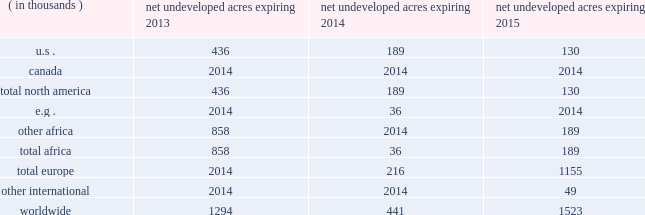In the ordinary course of business , based on our evaluations of certain geologic trends and prospective economics , we have allowed certain lease acreage to expire and may allow additional acreage to expire in the future .
If production is not established or we take no other action to extend the terms of the leases , licenses , or concessions , undeveloped acreage listed in the table below will expire over the next three years .
We plan to continue the terms of many of these licenses and concession areas or retain leases through operational or administrative actions. .
Marketing and midstream our e&p segment includes activities related to the marketing and transportation of substantially all of our liquid hydrocarbon and natural gas production .
These activities include the transportation of production to market centers , the sale of commodities to third parties and storage of production .
We balance our various sales , storage and transportation positions through what we call supply optimization , which can include the purchase of commodities from third parties for resale .
Supply optimization serves to aggregate volumes in order to satisfy transportation commitments and to achieve flexibility within product types and delivery points .
As discussed previously , we currently own and operate gathering systems and other midstream assets in some of our production areas .
We are continually evaluating value-added investments in midstream infrastructure or in capacity in third-party systems .
Delivery commitments we have committed to deliver quantities of crude oil and natural gas to customers under a variety of contracts .
As of december 31 , 2012 , those contracts for fixed and determinable amounts relate primarily to eagle ford liquid hydrocarbon production .
A minimum of 54 mbbld is to be delivered at variable pricing through mid-2017 under two contracts .
Our current production rates and proved reserves related to the eagle ford shale are sufficient to meet these commitments , but the contracts also provide for a monetary shortfall penalty or delivery of third-party volumes .
Oil sands mining segment we hold a 20 percent non-operated interest in the aosp , an oil sands mining and upgrading joint venture located in alberta , canada .
The joint venture produces bitumen from oil sands deposits in the athabasca region utilizing mining techniques and upgrades the bitumen to synthetic crude oils and vacuum gas oil .
The aosp 2019s mining and extraction assets are located near fort mcmurray , alberta and include the muskeg river and the jackpine mines .
Gross design capacity of the combined mines is 255000 ( 51000 net to our interest ) barrels of bitumen per day .
The aosp base and expansion 1 scotford upgrader is at fort saskatchewan , northeast of edmonton , alberta .
As of december 31 , 2012 , we own or have rights to participate in developed and undeveloped leases totaling approximately 216000 gross ( 43000 net ) acres .
The underlying developed leases are held for the duration of the project , with royalties payable to the province of alberta .
The five year aosp expansion 1 was completed in 2011 .
The jackpine mine commenced production under a phased start- up in the third quarter of 2010 and began supplying oil sands ore to the base processing facility in the fourth quarter of 2010 .
The upgrader expansion was completed and commenced operations in the second quarter of 2011 .
Synthetic crude oil sales volumes for 2012 were 47 mbbld and net of royalty production was 41 mbbld .
Phase one of debottlenecking opportunities was approved in 2011 and is expected to be completed in the second quarter of 2013 .
Future expansions and additional debottlenecking opportunities remain under review with no formal approvals expected until 2014 .
Current aosp operations use established processes to mine oil sands deposits from an open-pit mine , extract the bitumen and upgrade it into synthetic crude oils .
Ore is mined using traditional truck and shovel mining techniques .
The mined ore passes through primary crushers to reduce the ore chunks in size and is then sent to rotary breakers where the ore chunks are further reduced to smaller particles .
The particles are combined with hot water to create slurry .
The slurry moves through the extraction .
What percent of net expiring acres in 2013 are foreign? 
Rationale: not in us - foreign
Computations: ((1294 - 436) / 1294)
Answer: 0.66306. 